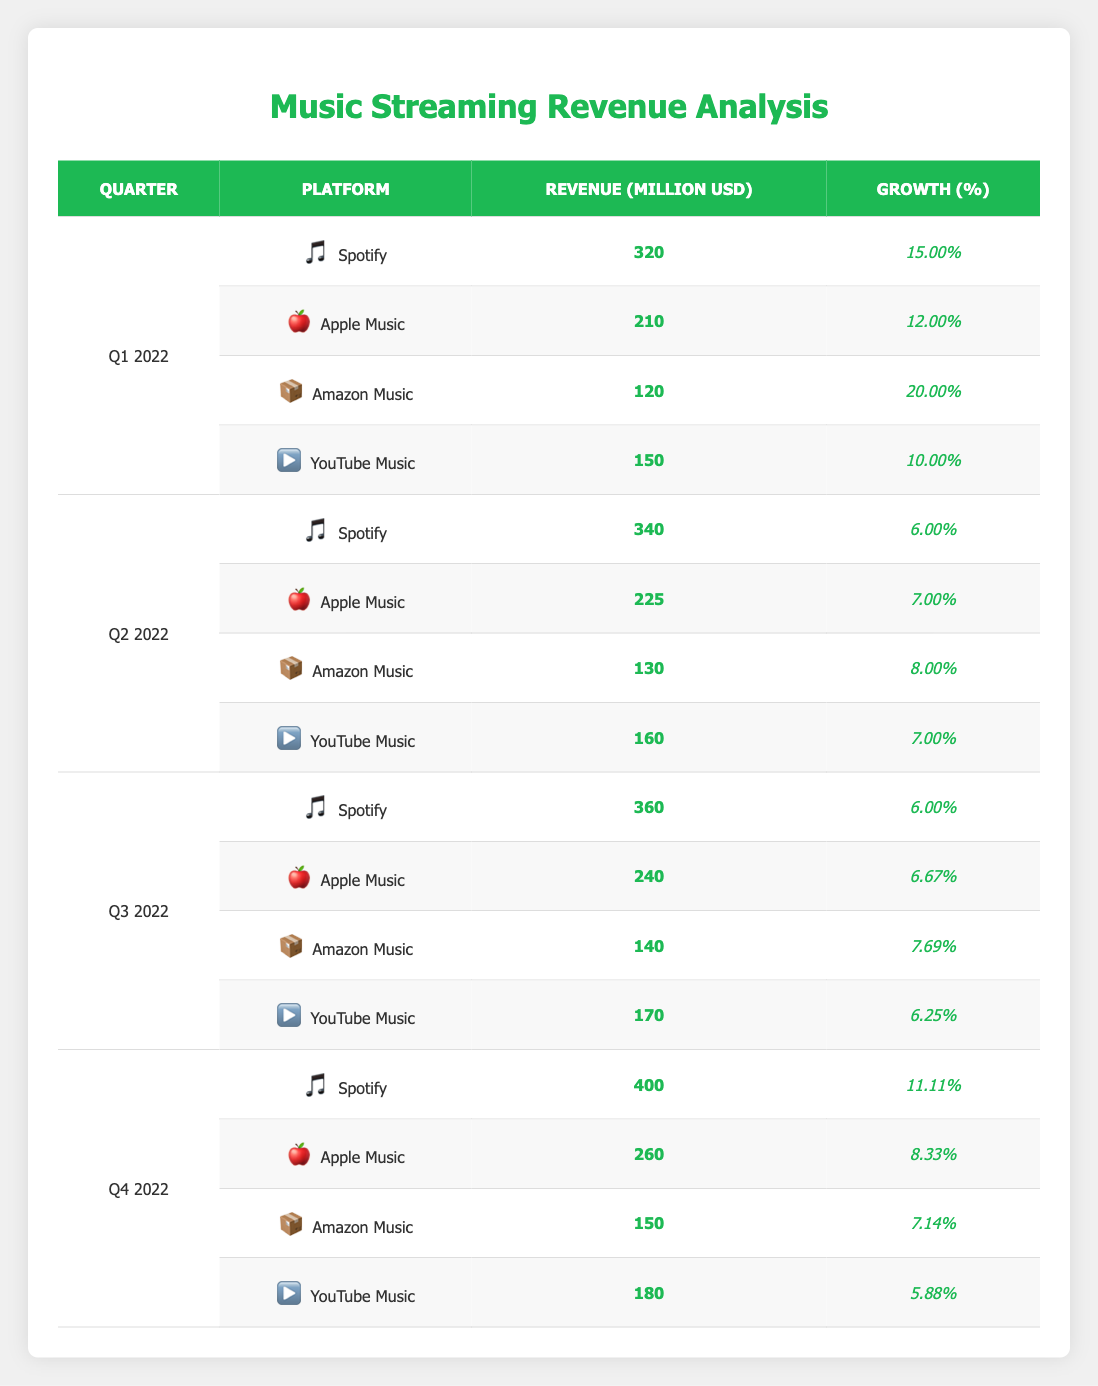What is the total revenue from music streaming services for Q1 2022? To find the total revenue for Q1 2022, add the revenue for each platform during that quarter: 320 (Spotify) + 210 (Apple Music) + 120 (Amazon Music) + 150 (YouTube Music) = 800 million USD
Answer: 800 million USD Which platform had the highest revenue in Q4 2022? In Q4 2022, the revenues for each platform were: Spotify 400, Apple Music 260, Amazon Music 150, and YouTube Music 180. Comparing these figures, Spotify had the highest revenue at 400 million USD
Answer: Spotify What was the percentage growth of Apple Music from Q3 2022 to Q4 2022? To calculate the percentage growth, take the revenue for Q4 2022 (260) minus the revenue for Q3 2022 (240), which is 20, then divide by the Q3 revenue (240) and multiply by 100: (20/240) * 100 = 8.33%
Answer: 8.33% Did Amazon Music experience a decline in revenue at any point during 2022? Looking at the data for Amazon Music, the revenues were: Q1 2022 (120), Q2 2022 (130), Q3 2022 (140), and Q4 2022 (150). Since the revenue increased each quarter, it did not experience a decline
Answer: No What was the average revenue across all platforms for Q2 2022? For Q2 2022, the revenues are: Spotify 340, Apple Music 225, Amazon Music 130, and YouTube Music 160. To find the average, add these values: 340 + 225 + 130 + 160 = 855, then divide by the number of platforms (4): 855/4 = 213.75 million USD
Answer: 213.75 million USD What was the total revenue from Spotify over all four quarters of 2022? Adding the revenue for Spotify across all quarters: Q1 (320), Q2 (340), Q3 (360), and Q4 (400). The total is 320 + 340 + 360 + 400 = 1420 million USD
Answer: 1420 million USD Which quarter showed the highest revenue growth for YouTube Music and what was the growth percentage? The revenues for YouTube Music were as follows: Q1 2022 (150), Q2 2022 (160), Q3 2022 (170), Q4 2022 (180). The growth percentages were: 10% (Q1 to Q2), 6.25% (Q2 to Q3), and 5.88% (Q3 to Q4). The highest growth was from Q1 to Q2 at 10%
Answer: Q2 2022 with 10% growth Was there any quarter where Apple Music had a revenue greater than Amazon Music? Checking the revenues for each quarter, Apple Music had revenues of 210, 225, 240, and 260 while Amazon Music had 120, 130, 140, and 150. In every quarter, Apple Music's revenue exceeded that of Amazon Music
Answer: Yes 